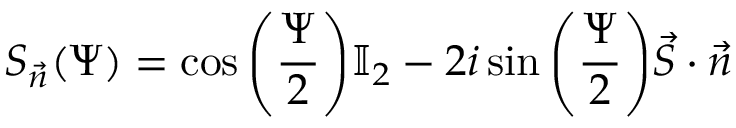Convert formula to latex. <formula><loc_0><loc_0><loc_500><loc_500>S _ { \vec { n } } ( \Psi ) = \cos { \left ( \frac { \Psi } { 2 } \right ) } \mathbb { I } _ { 2 } - 2 i \sin { \left ( \frac { \Psi } { 2 } \right ) } \vec { S } \cdot \vec { n }</formula> 